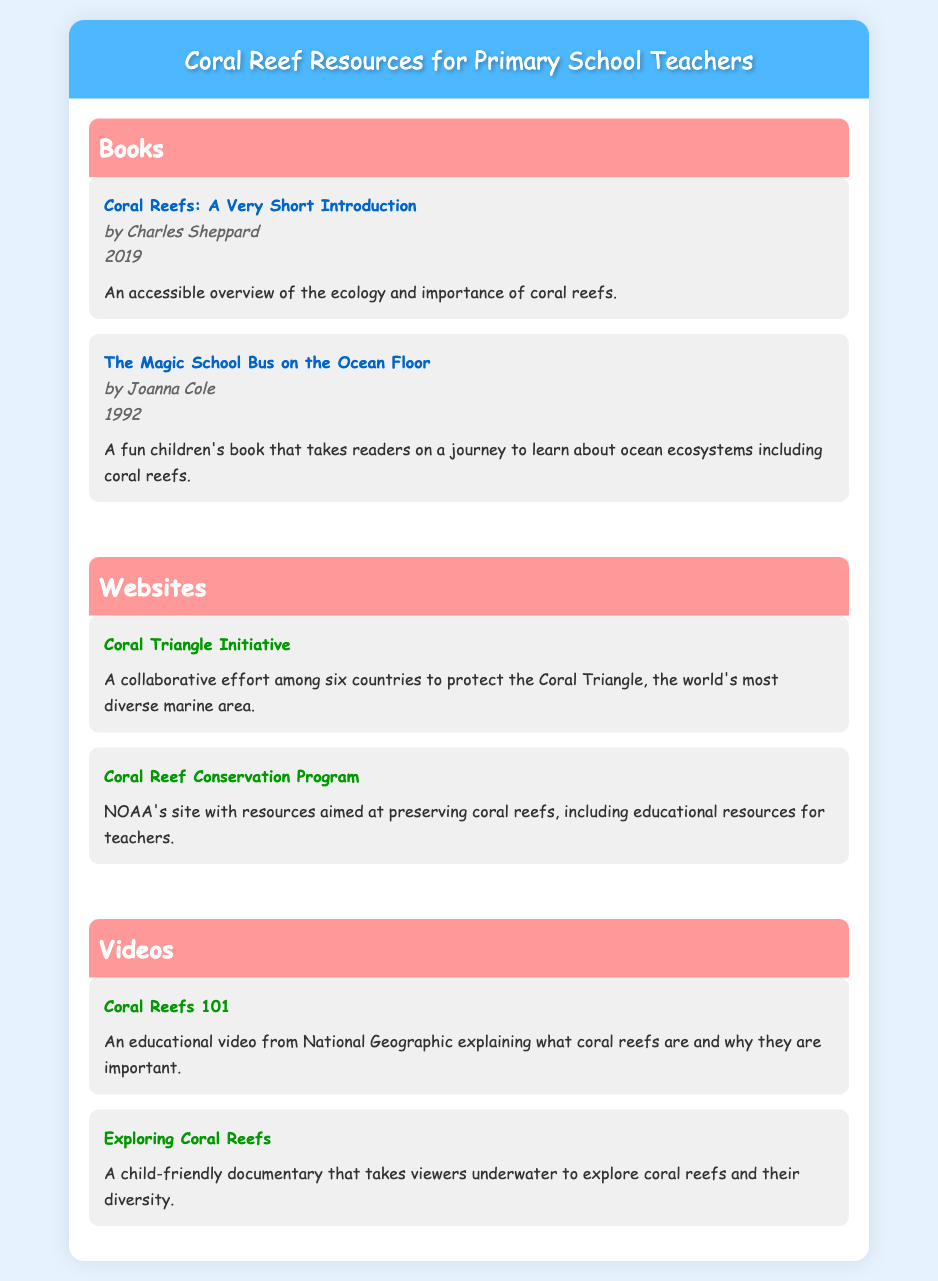What is the title of a book about coral reefs? The document lists several books, one of which is titled "Coral Reefs: A Very Short Introduction."
Answer: Coral Reefs: A Very Short Introduction Who is the author of "The Magic School Bus on the Ocean Floor"? The document provides the author's name for this book, which is Joanna Cole.
Answer: Joanna Cole In what year was "Coral Reefs: A Very Short Introduction" published? The publication year for this book is mentioned in the document as 2019.
Answer: 2019 What is the website for the Coral Triangle Initiative? The document provides a link to the Coral Triangle Initiative's website. The URL is included in the text.
Answer: https://www.coraltriangleinitiative.org Which organization has a Coral Reef Conservation Program? The document notes that NOAA has a Coral Reef Conservation Program with educational resources for teachers.
Answer: NOAA How many videos about coral reefs are listed in the document? By counting the video entries in the document, we find there are two videos listed.
Answer: 2 What is the subject of the video "Coral Reefs 101"? The document specifies that this video explains what coral reefs are and their importance.
Answer: What coral reefs are and their importance What type of resources does NOAA's site provide? The document states that NOAA's site provides resources aimed at preserving coral reefs, including educational resources for teachers.
Answer: Educational resources for teachers 